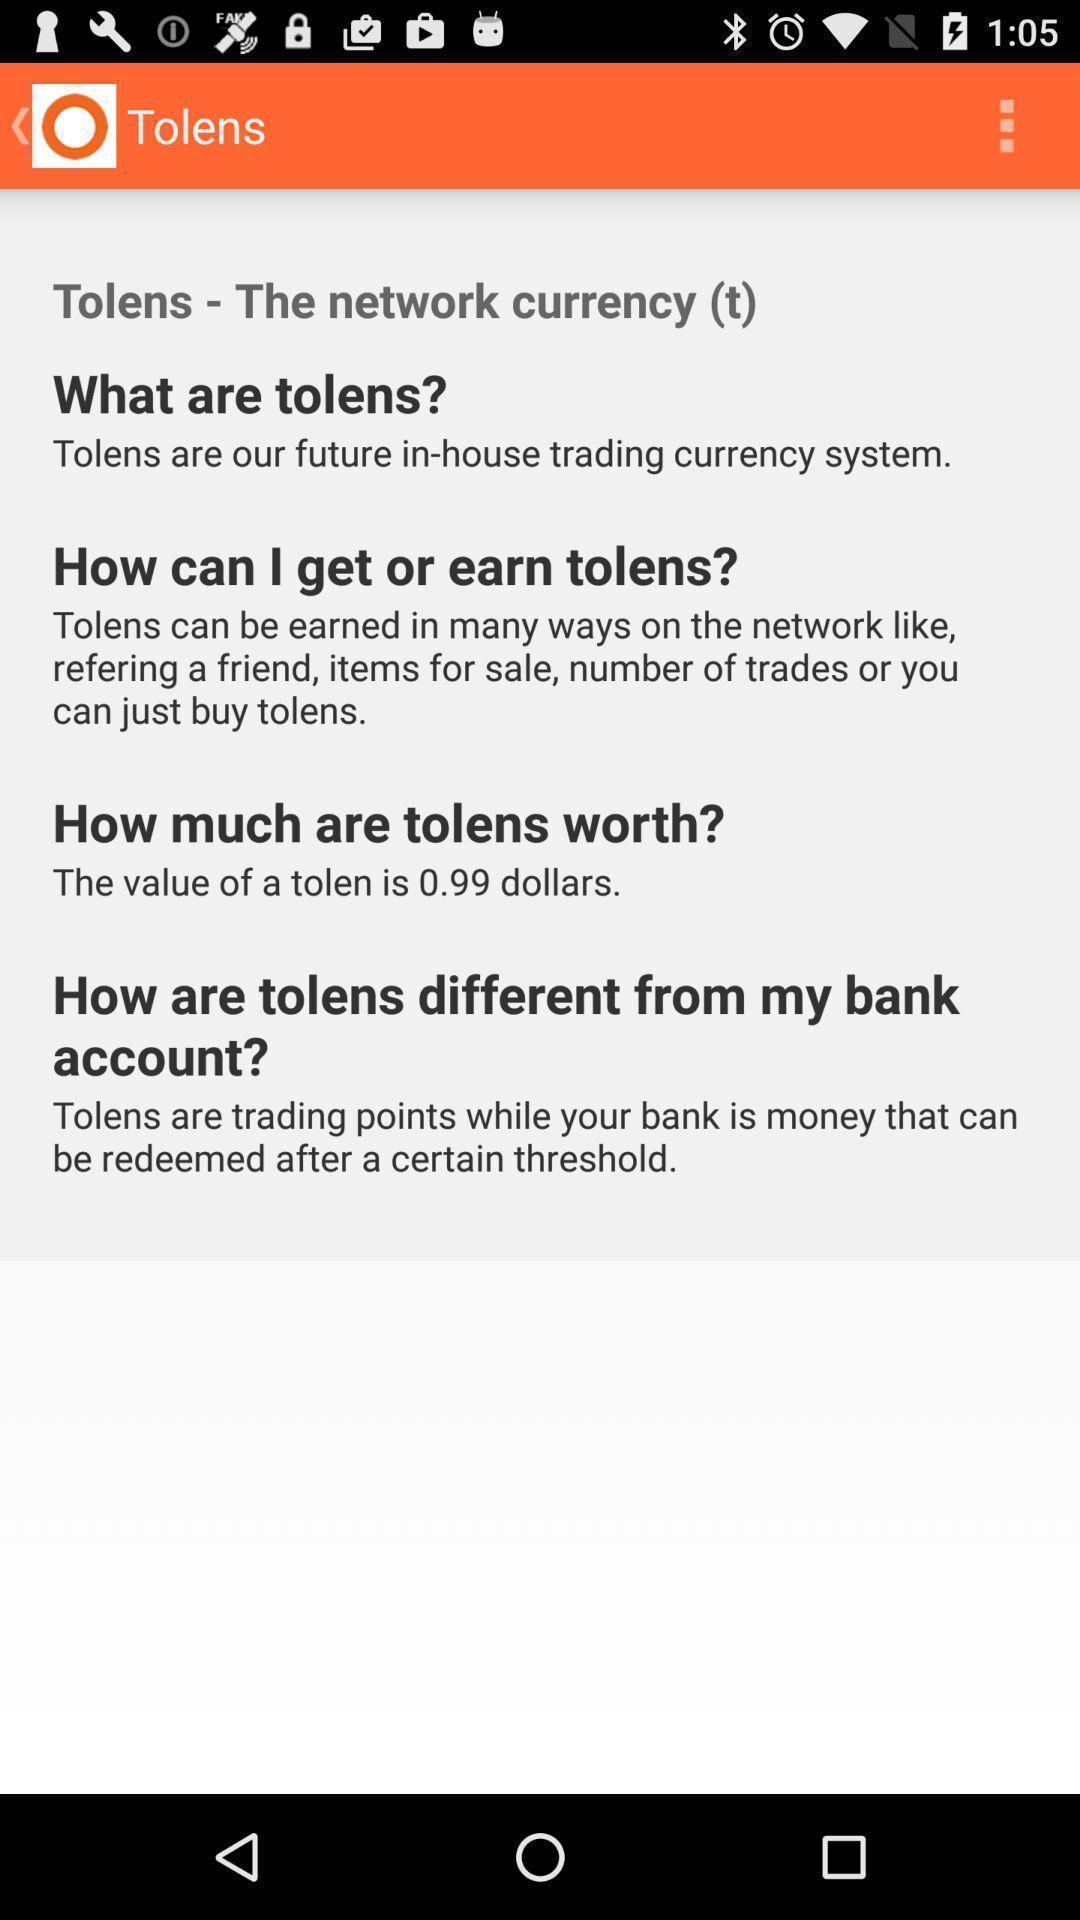Tell me about the visual elements in this screen capture. Screen page of a list of questions. 